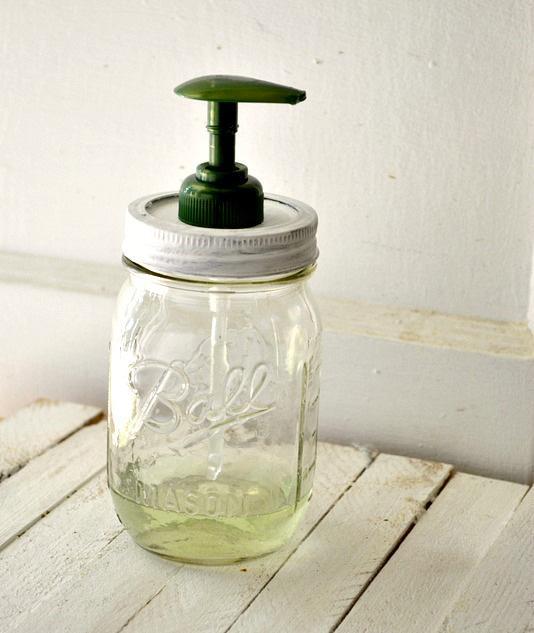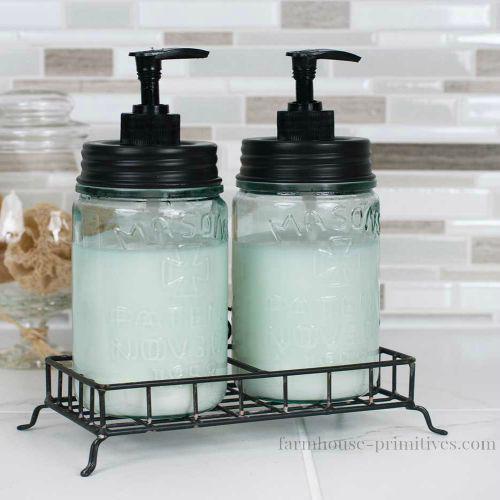The first image is the image on the left, the second image is the image on the right. Examine the images to the left and right. Is the description "At least one image shows exactly three containers." accurate? Answer yes or no. No. 